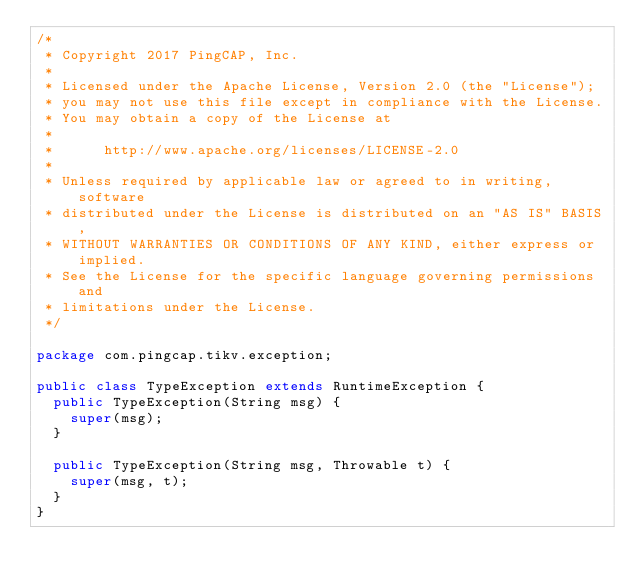Convert code to text. <code><loc_0><loc_0><loc_500><loc_500><_Java_>/*
 * Copyright 2017 PingCAP, Inc.
 *
 * Licensed under the Apache License, Version 2.0 (the "License");
 * you may not use this file except in compliance with the License.
 * You may obtain a copy of the License at
 *
 *      http://www.apache.org/licenses/LICENSE-2.0
 *
 * Unless required by applicable law or agreed to in writing, software
 * distributed under the License is distributed on an "AS IS" BASIS,
 * WITHOUT WARRANTIES OR CONDITIONS OF ANY KIND, either express or implied.
 * See the License for the specific language governing permissions and
 * limitations under the License.
 */

package com.pingcap.tikv.exception;

public class TypeException extends RuntimeException {
  public TypeException(String msg) {
    super(msg);
  }

  public TypeException(String msg, Throwable t) {
    super(msg, t);
  }
}
</code> 